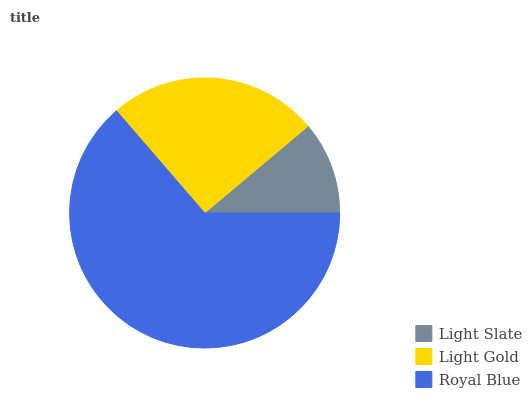Is Light Slate the minimum?
Answer yes or no. Yes. Is Royal Blue the maximum?
Answer yes or no. Yes. Is Light Gold the minimum?
Answer yes or no. No. Is Light Gold the maximum?
Answer yes or no. No. Is Light Gold greater than Light Slate?
Answer yes or no. Yes. Is Light Slate less than Light Gold?
Answer yes or no. Yes. Is Light Slate greater than Light Gold?
Answer yes or no. No. Is Light Gold less than Light Slate?
Answer yes or no. No. Is Light Gold the high median?
Answer yes or no. Yes. Is Light Gold the low median?
Answer yes or no. Yes. Is Light Slate the high median?
Answer yes or no. No. Is Royal Blue the low median?
Answer yes or no. No. 